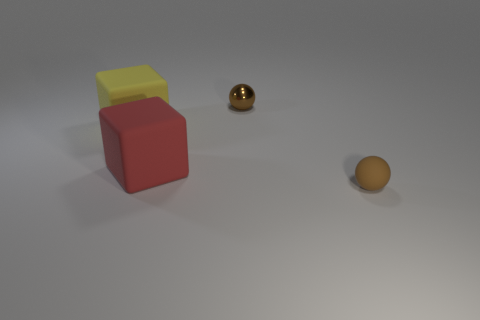There is a small rubber thing that is the same shape as the tiny brown metallic object; what color is it? The small rubber object that shares its shape with the tiny brown metallic object appears to be yellow in color, with a tinge of translucency suggesting it's made of a different material. 